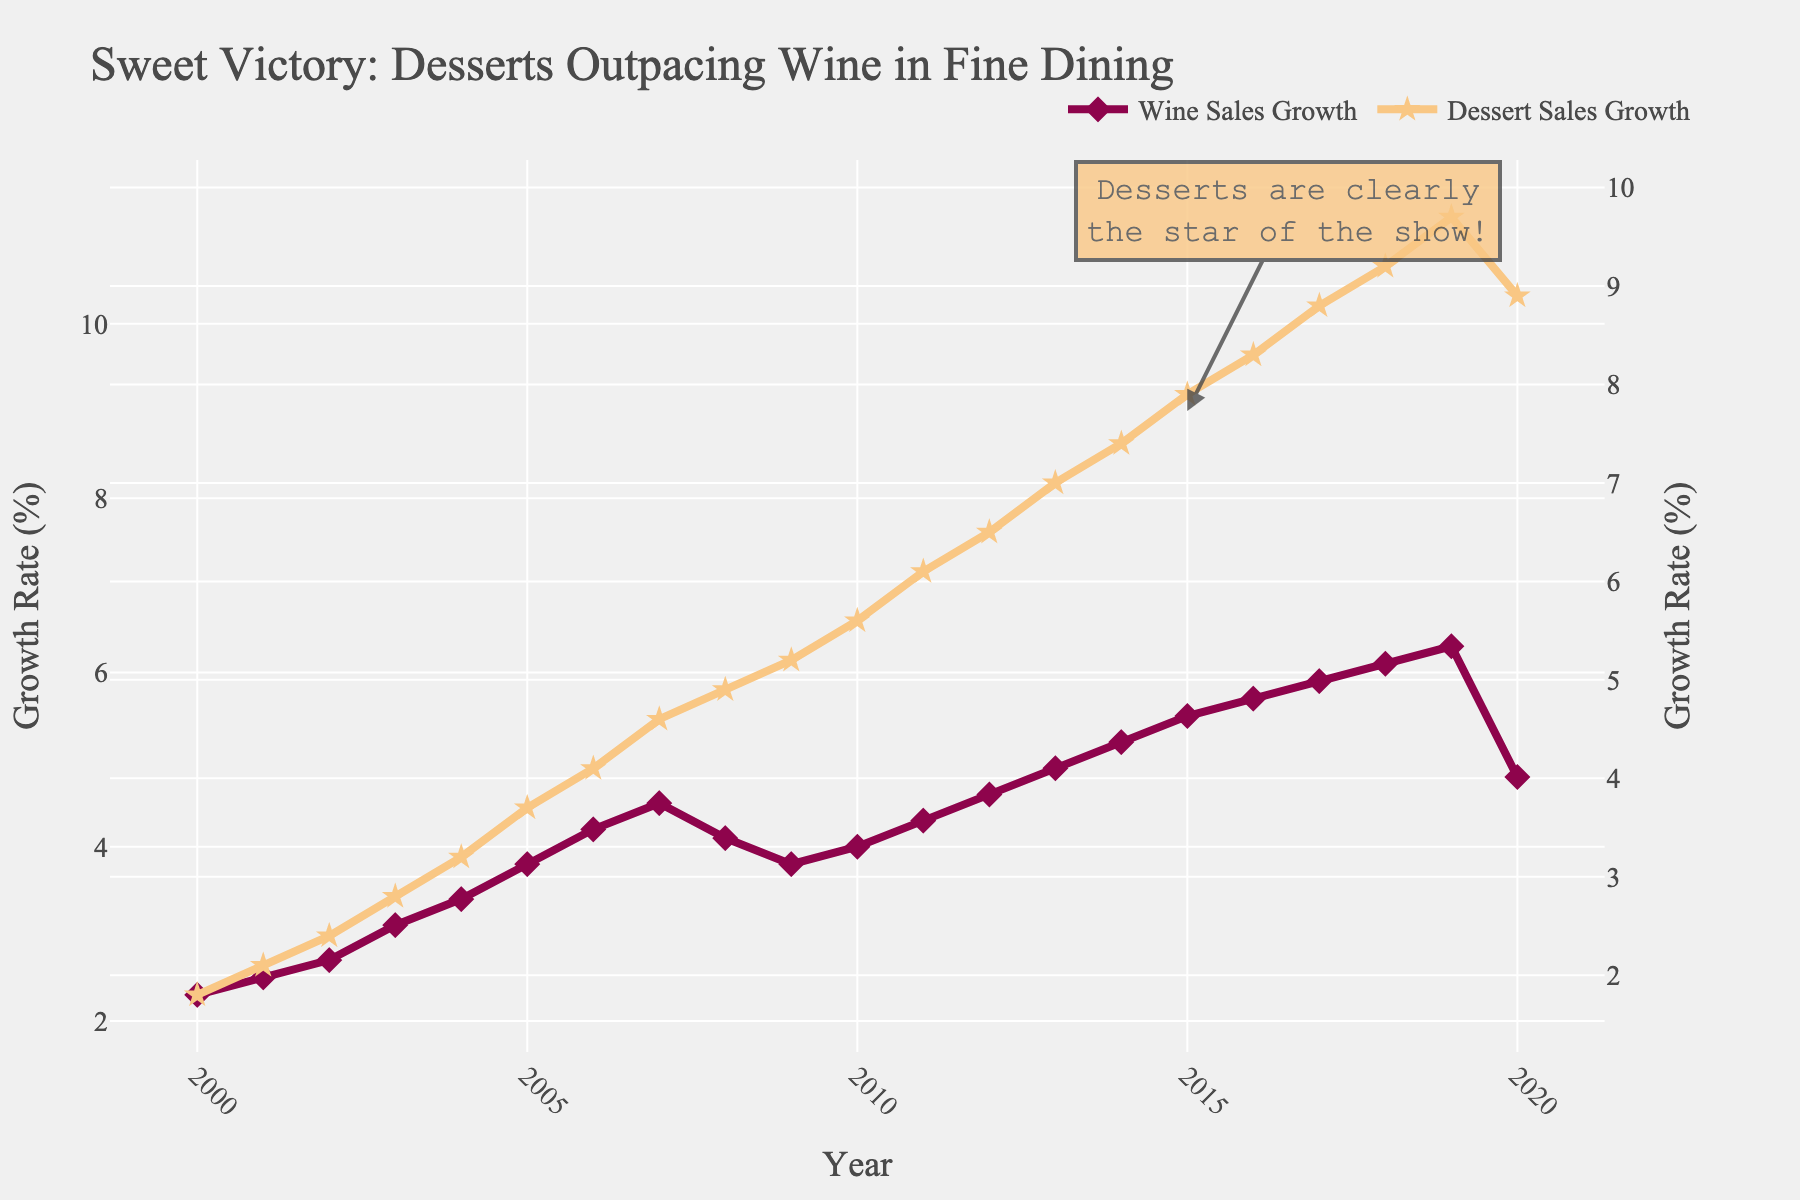What's the overall trend in dessert sales growth from 2000 to 2020? The line for dessert sales growth consistently increases over the years, peaking around 2019 before slightly declining in 2020.
Answer: Increasing Which year had the highest wine sales growth? The highest point on the wine sales growth line occurs in 2019.
Answer: 2019 Compare the dessert sales growth in 2008 and 2011. Which year had higher growth? The line for dessert sales growth is higher in 2011 than in 2008, indicating that 2011 had higher growth.
Answer: 2011 What is the average dessert sales growth over the two decades? Sum each year's dessert sales growth percentage and then divide by the number of years (20). (1.8 + 2.1 + 2.4 + 2.8 + 3.2 + 3.7 + 4.1 + 4.6 + 4.9 + 5.2 + 5.6 + 6.1 + 6.5 + 7.0 + 7.4 + 7.9 + 8.3 + 8.8 + 9.2 + 8.9) / 20 = 5.07
Answer: 5.07% What does the annotation in the plot indicate? The annotation points to 2015 and states "Desserts are clearly the star of the show," highlighting the significant growth in dessert sales at that time.
Answer: Significant dessert growth in 2015 In which year did dessert sales growth first exceed wine sales growth? The dessert sales growth line first appears above the wine sales growth line in 2008.
Answer: 2008 By how much did wine sales growth change between 2019 and 2020? The wine sales growth decreased from 6.3% in 2019 to 4.8% in 2020. The change is 6.3% - 4.8% = 1.5%.
Answer: 1.5% Which had greater growth in 2017, wine sales or dessert sales? The dessert sales growth line is higher than the wine sales growth line in 2017.
Answer: Dessert sales How much did dessert sales growth increase from 2004 to 2014? Dessert sales growth increased from 3.2% in 2004 to 7.4% in 2014. The increase is 7.4% - 3.2% = 4.2%.
Answer: 4.2% What was the peak growth rate for dessert sales? The highest point on the dessert sales growth line is in 2019, with a peak growth rate of 9.7%.
Answer: 9.7% 